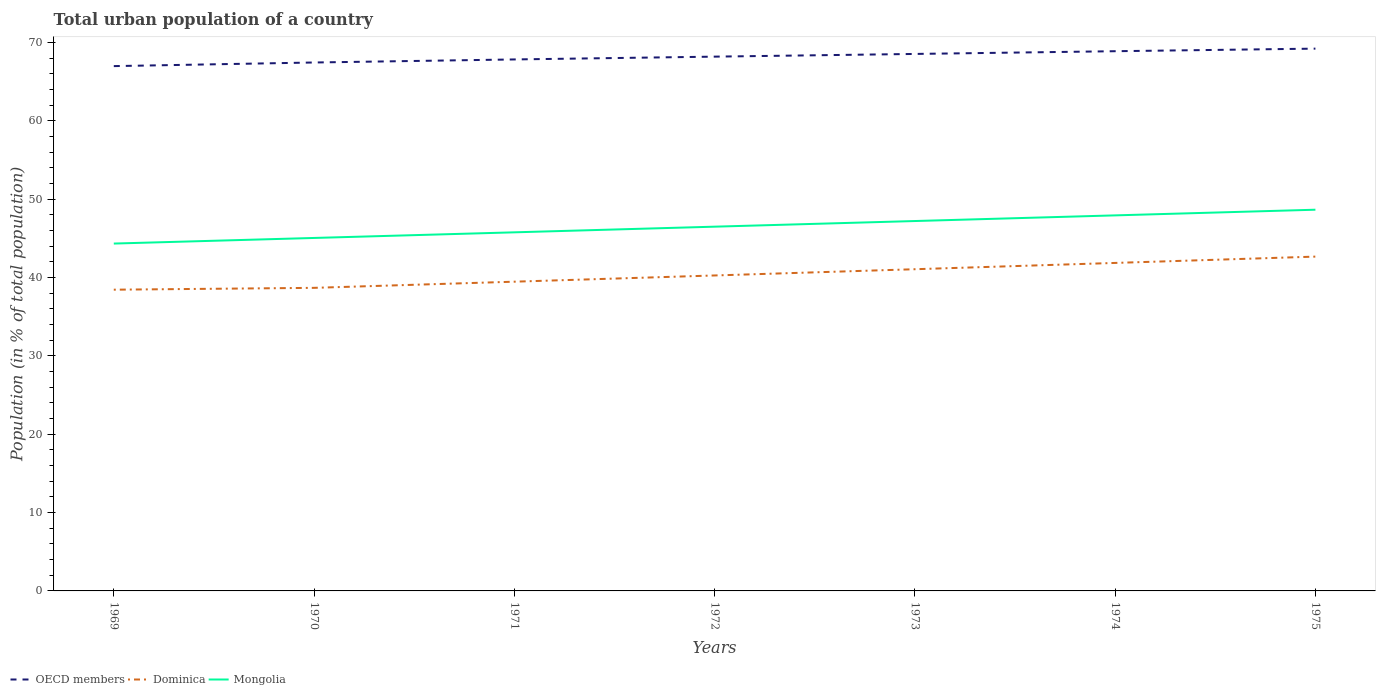How many different coloured lines are there?
Your response must be concise. 3. Is the number of lines equal to the number of legend labels?
Make the answer very short. Yes. Across all years, what is the maximum urban population in OECD members?
Your answer should be very brief. 66.98. In which year was the urban population in OECD members maximum?
Keep it short and to the point. 1969. What is the total urban population in Dominica in the graph?
Keep it short and to the point. -1.82. What is the difference between the highest and the second highest urban population in Dominica?
Your answer should be very brief. 4.22. What is the difference between the highest and the lowest urban population in Dominica?
Offer a terse response. 3. Is the urban population in Mongolia strictly greater than the urban population in OECD members over the years?
Offer a terse response. Yes. How many lines are there?
Provide a succinct answer. 3. Are the values on the major ticks of Y-axis written in scientific E-notation?
Your response must be concise. No. Does the graph contain grids?
Provide a short and direct response. No. Where does the legend appear in the graph?
Give a very brief answer. Bottom left. What is the title of the graph?
Make the answer very short. Total urban population of a country. What is the label or title of the X-axis?
Make the answer very short. Years. What is the label or title of the Y-axis?
Offer a very short reply. Population (in % of total population). What is the Population (in % of total population) of OECD members in 1969?
Provide a short and direct response. 66.98. What is the Population (in % of total population) in Dominica in 1969?
Your answer should be compact. 38.45. What is the Population (in % of total population) in Mongolia in 1969?
Your answer should be very brief. 44.34. What is the Population (in % of total population) of OECD members in 1970?
Your response must be concise. 67.45. What is the Population (in % of total population) in Dominica in 1970?
Offer a terse response. 38.68. What is the Population (in % of total population) in Mongolia in 1970?
Give a very brief answer. 45.05. What is the Population (in % of total population) in OECD members in 1971?
Offer a very short reply. 67.84. What is the Population (in % of total population) of Dominica in 1971?
Give a very brief answer. 39.47. What is the Population (in % of total population) in Mongolia in 1971?
Your response must be concise. 45.77. What is the Population (in % of total population) in OECD members in 1972?
Keep it short and to the point. 68.19. What is the Population (in % of total population) of Dominica in 1972?
Ensure brevity in your answer.  40.26. What is the Population (in % of total population) in Mongolia in 1972?
Keep it short and to the point. 46.49. What is the Population (in % of total population) in OECD members in 1973?
Keep it short and to the point. 68.54. What is the Population (in % of total population) in Dominica in 1973?
Offer a very short reply. 41.06. What is the Population (in % of total population) of Mongolia in 1973?
Your response must be concise. 47.21. What is the Population (in % of total population) of OECD members in 1974?
Provide a short and direct response. 68.89. What is the Population (in % of total population) of Dominica in 1974?
Your answer should be very brief. 41.86. What is the Population (in % of total population) of Mongolia in 1974?
Keep it short and to the point. 47.93. What is the Population (in % of total population) in OECD members in 1975?
Your answer should be compact. 69.22. What is the Population (in % of total population) of Dominica in 1975?
Give a very brief answer. 42.67. What is the Population (in % of total population) of Mongolia in 1975?
Provide a short and direct response. 48.66. Across all years, what is the maximum Population (in % of total population) of OECD members?
Give a very brief answer. 69.22. Across all years, what is the maximum Population (in % of total population) of Dominica?
Provide a short and direct response. 42.67. Across all years, what is the maximum Population (in % of total population) in Mongolia?
Offer a very short reply. 48.66. Across all years, what is the minimum Population (in % of total population) in OECD members?
Provide a short and direct response. 66.98. Across all years, what is the minimum Population (in % of total population) of Dominica?
Your answer should be compact. 38.45. Across all years, what is the minimum Population (in % of total population) of Mongolia?
Your answer should be very brief. 44.34. What is the total Population (in % of total population) in OECD members in the graph?
Give a very brief answer. 477.1. What is the total Population (in % of total population) of Dominica in the graph?
Ensure brevity in your answer.  282.46. What is the total Population (in % of total population) of Mongolia in the graph?
Your answer should be very brief. 325.45. What is the difference between the Population (in % of total population) in OECD members in 1969 and that in 1970?
Make the answer very short. -0.46. What is the difference between the Population (in % of total population) of Dominica in 1969 and that in 1970?
Give a very brief answer. -0.23. What is the difference between the Population (in % of total population) in Mongolia in 1969 and that in 1970?
Offer a very short reply. -0.72. What is the difference between the Population (in % of total population) in OECD members in 1969 and that in 1971?
Keep it short and to the point. -0.85. What is the difference between the Population (in % of total population) of Dominica in 1969 and that in 1971?
Give a very brief answer. -1.02. What is the difference between the Population (in % of total population) in Mongolia in 1969 and that in 1971?
Your answer should be very brief. -1.43. What is the difference between the Population (in % of total population) of OECD members in 1969 and that in 1972?
Your answer should be very brief. -1.21. What is the difference between the Population (in % of total population) of Dominica in 1969 and that in 1972?
Provide a succinct answer. -1.82. What is the difference between the Population (in % of total population) of Mongolia in 1969 and that in 1972?
Offer a very short reply. -2.15. What is the difference between the Population (in % of total population) of OECD members in 1969 and that in 1973?
Offer a very short reply. -1.55. What is the difference between the Population (in % of total population) of Dominica in 1969 and that in 1973?
Give a very brief answer. -2.61. What is the difference between the Population (in % of total population) of Mongolia in 1969 and that in 1973?
Offer a terse response. -2.88. What is the difference between the Population (in % of total population) of OECD members in 1969 and that in 1974?
Offer a very short reply. -1.9. What is the difference between the Population (in % of total population) in Dominica in 1969 and that in 1974?
Offer a terse response. -3.42. What is the difference between the Population (in % of total population) in Mongolia in 1969 and that in 1974?
Ensure brevity in your answer.  -3.6. What is the difference between the Population (in % of total population) in OECD members in 1969 and that in 1975?
Give a very brief answer. -2.23. What is the difference between the Population (in % of total population) of Dominica in 1969 and that in 1975?
Keep it short and to the point. -4.22. What is the difference between the Population (in % of total population) of Mongolia in 1969 and that in 1975?
Your answer should be compact. -4.32. What is the difference between the Population (in % of total population) in OECD members in 1970 and that in 1971?
Keep it short and to the point. -0.39. What is the difference between the Population (in % of total population) of Dominica in 1970 and that in 1971?
Offer a terse response. -0.79. What is the difference between the Population (in % of total population) in Mongolia in 1970 and that in 1971?
Provide a succinct answer. -0.72. What is the difference between the Population (in % of total population) of OECD members in 1970 and that in 1972?
Keep it short and to the point. -0.75. What is the difference between the Population (in % of total population) in Dominica in 1970 and that in 1972?
Your answer should be compact. -1.58. What is the difference between the Population (in % of total population) of Mongolia in 1970 and that in 1972?
Keep it short and to the point. -1.44. What is the difference between the Population (in % of total population) of OECD members in 1970 and that in 1973?
Offer a very short reply. -1.09. What is the difference between the Population (in % of total population) in Dominica in 1970 and that in 1973?
Offer a very short reply. -2.38. What is the difference between the Population (in % of total population) of Mongolia in 1970 and that in 1973?
Your response must be concise. -2.16. What is the difference between the Population (in % of total population) in OECD members in 1970 and that in 1974?
Offer a terse response. -1.44. What is the difference between the Population (in % of total population) in Dominica in 1970 and that in 1974?
Offer a terse response. -3.18. What is the difference between the Population (in % of total population) of Mongolia in 1970 and that in 1974?
Make the answer very short. -2.88. What is the difference between the Population (in % of total population) in OECD members in 1970 and that in 1975?
Ensure brevity in your answer.  -1.77. What is the difference between the Population (in % of total population) in Dominica in 1970 and that in 1975?
Your answer should be very brief. -3.99. What is the difference between the Population (in % of total population) in Mongolia in 1970 and that in 1975?
Your answer should be compact. -3.6. What is the difference between the Population (in % of total population) of OECD members in 1971 and that in 1972?
Offer a very short reply. -0.36. What is the difference between the Population (in % of total population) of Dominica in 1971 and that in 1972?
Offer a very short reply. -0.79. What is the difference between the Population (in % of total population) of Mongolia in 1971 and that in 1972?
Provide a short and direct response. -0.72. What is the difference between the Population (in % of total population) in OECD members in 1971 and that in 1973?
Give a very brief answer. -0.7. What is the difference between the Population (in % of total population) of Dominica in 1971 and that in 1973?
Provide a succinct answer. -1.59. What is the difference between the Population (in % of total population) in Mongolia in 1971 and that in 1973?
Your response must be concise. -1.44. What is the difference between the Population (in % of total population) of OECD members in 1971 and that in 1974?
Give a very brief answer. -1.05. What is the difference between the Population (in % of total population) in Dominica in 1971 and that in 1974?
Your answer should be very brief. -2.39. What is the difference between the Population (in % of total population) in Mongolia in 1971 and that in 1974?
Keep it short and to the point. -2.16. What is the difference between the Population (in % of total population) in OECD members in 1971 and that in 1975?
Your response must be concise. -1.38. What is the difference between the Population (in % of total population) of Dominica in 1971 and that in 1975?
Your answer should be compact. -3.2. What is the difference between the Population (in % of total population) in Mongolia in 1971 and that in 1975?
Ensure brevity in your answer.  -2.89. What is the difference between the Population (in % of total population) of OECD members in 1972 and that in 1973?
Offer a terse response. -0.34. What is the difference between the Population (in % of total population) of Dominica in 1972 and that in 1973?
Offer a very short reply. -0.8. What is the difference between the Population (in % of total population) of Mongolia in 1972 and that in 1973?
Offer a very short reply. -0.72. What is the difference between the Population (in % of total population) of OECD members in 1972 and that in 1974?
Provide a short and direct response. -0.69. What is the difference between the Population (in % of total population) in Mongolia in 1972 and that in 1974?
Ensure brevity in your answer.  -1.44. What is the difference between the Population (in % of total population) in OECD members in 1972 and that in 1975?
Your answer should be very brief. -1.02. What is the difference between the Population (in % of total population) in Dominica in 1972 and that in 1975?
Your response must be concise. -2.41. What is the difference between the Population (in % of total population) of Mongolia in 1972 and that in 1975?
Give a very brief answer. -2.17. What is the difference between the Population (in % of total population) of OECD members in 1973 and that in 1974?
Provide a short and direct response. -0.35. What is the difference between the Population (in % of total population) of Dominica in 1973 and that in 1974?
Your response must be concise. -0.8. What is the difference between the Population (in % of total population) of Mongolia in 1973 and that in 1974?
Keep it short and to the point. -0.72. What is the difference between the Population (in % of total population) of OECD members in 1973 and that in 1975?
Keep it short and to the point. -0.68. What is the difference between the Population (in % of total population) in Dominica in 1973 and that in 1975?
Offer a very short reply. -1.61. What is the difference between the Population (in % of total population) of Mongolia in 1973 and that in 1975?
Provide a succinct answer. -1.45. What is the difference between the Population (in % of total population) of OECD members in 1974 and that in 1975?
Your answer should be compact. -0.33. What is the difference between the Population (in % of total population) of Dominica in 1974 and that in 1975?
Provide a short and direct response. -0.81. What is the difference between the Population (in % of total population) in Mongolia in 1974 and that in 1975?
Provide a short and direct response. -0.72. What is the difference between the Population (in % of total population) of OECD members in 1969 and the Population (in % of total population) of Dominica in 1970?
Keep it short and to the point. 28.3. What is the difference between the Population (in % of total population) in OECD members in 1969 and the Population (in % of total population) in Mongolia in 1970?
Your answer should be very brief. 21.93. What is the difference between the Population (in % of total population) of Dominica in 1969 and the Population (in % of total population) of Mongolia in 1970?
Keep it short and to the point. -6.6. What is the difference between the Population (in % of total population) of OECD members in 1969 and the Population (in % of total population) of Dominica in 1971?
Ensure brevity in your answer.  27.51. What is the difference between the Population (in % of total population) of OECD members in 1969 and the Population (in % of total population) of Mongolia in 1971?
Your answer should be compact. 21.21. What is the difference between the Population (in % of total population) of Dominica in 1969 and the Population (in % of total population) of Mongolia in 1971?
Provide a succinct answer. -7.32. What is the difference between the Population (in % of total population) of OECD members in 1969 and the Population (in % of total population) of Dominica in 1972?
Provide a succinct answer. 26.72. What is the difference between the Population (in % of total population) in OECD members in 1969 and the Population (in % of total population) in Mongolia in 1972?
Give a very brief answer. 20.49. What is the difference between the Population (in % of total population) in Dominica in 1969 and the Population (in % of total population) in Mongolia in 1972?
Provide a succinct answer. -8.04. What is the difference between the Population (in % of total population) of OECD members in 1969 and the Population (in % of total population) of Dominica in 1973?
Offer a terse response. 25.92. What is the difference between the Population (in % of total population) in OECD members in 1969 and the Population (in % of total population) in Mongolia in 1973?
Give a very brief answer. 19.77. What is the difference between the Population (in % of total population) in Dominica in 1969 and the Population (in % of total population) in Mongolia in 1973?
Your answer should be compact. -8.76. What is the difference between the Population (in % of total population) of OECD members in 1969 and the Population (in % of total population) of Dominica in 1974?
Keep it short and to the point. 25.12. What is the difference between the Population (in % of total population) of OECD members in 1969 and the Population (in % of total population) of Mongolia in 1974?
Offer a very short reply. 19.05. What is the difference between the Population (in % of total population) in Dominica in 1969 and the Population (in % of total population) in Mongolia in 1974?
Give a very brief answer. -9.48. What is the difference between the Population (in % of total population) of OECD members in 1969 and the Population (in % of total population) of Dominica in 1975?
Keep it short and to the point. 24.31. What is the difference between the Population (in % of total population) in OECD members in 1969 and the Population (in % of total population) in Mongolia in 1975?
Your response must be concise. 18.33. What is the difference between the Population (in % of total population) in Dominica in 1969 and the Population (in % of total population) in Mongolia in 1975?
Provide a succinct answer. -10.21. What is the difference between the Population (in % of total population) in OECD members in 1970 and the Population (in % of total population) in Dominica in 1971?
Offer a terse response. 27.98. What is the difference between the Population (in % of total population) of OECD members in 1970 and the Population (in % of total population) of Mongolia in 1971?
Your response must be concise. 21.68. What is the difference between the Population (in % of total population) of Dominica in 1970 and the Population (in % of total population) of Mongolia in 1971?
Provide a short and direct response. -7.09. What is the difference between the Population (in % of total population) in OECD members in 1970 and the Population (in % of total population) in Dominica in 1972?
Your response must be concise. 27.18. What is the difference between the Population (in % of total population) in OECD members in 1970 and the Population (in % of total population) in Mongolia in 1972?
Offer a very short reply. 20.95. What is the difference between the Population (in % of total population) of Dominica in 1970 and the Population (in % of total population) of Mongolia in 1972?
Your answer should be compact. -7.81. What is the difference between the Population (in % of total population) in OECD members in 1970 and the Population (in % of total population) in Dominica in 1973?
Give a very brief answer. 26.38. What is the difference between the Population (in % of total population) of OECD members in 1970 and the Population (in % of total population) of Mongolia in 1973?
Provide a short and direct response. 20.23. What is the difference between the Population (in % of total population) in Dominica in 1970 and the Population (in % of total population) in Mongolia in 1973?
Provide a succinct answer. -8.53. What is the difference between the Population (in % of total population) in OECD members in 1970 and the Population (in % of total population) in Dominica in 1974?
Provide a short and direct response. 25.58. What is the difference between the Population (in % of total population) of OECD members in 1970 and the Population (in % of total population) of Mongolia in 1974?
Provide a short and direct response. 19.51. What is the difference between the Population (in % of total population) in Dominica in 1970 and the Population (in % of total population) in Mongolia in 1974?
Keep it short and to the point. -9.25. What is the difference between the Population (in % of total population) of OECD members in 1970 and the Population (in % of total population) of Dominica in 1975?
Ensure brevity in your answer.  24.77. What is the difference between the Population (in % of total population) of OECD members in 1970 and the Population (in % of total population) of Mongolia in 1975?
Make the answer very short. 18.79. What is the difference between the Population (in % of total population) of Dominica in 1970 and the Population (in % of total population) of Mongolia in 1975?
Make the answer very short. -9.97. What is the difference between the Population (in % of total population) in OECD members in 1971 and the Population (in % of total population) in Dominica in 1972?
Ensure brevity in your answer.  27.57. What is the difference between the Population (in % of total population) of OECD members in 1971 and the Population (in % of total population) of Mongolia in 1972?
Offer a very short reply. 21.34. What is the difference between the Population (in % of total population) of Dominica in 1971 and the Population (in % of total population) of Mongolia in 1972?
Provide a short and direct response. -7.02. What is the difference between the Population (in % of total population) in OECD members in 1971 and the Population (in % of total population) in Dominica in 1973?
Offer a terse response. 26.77. What is the difference between the Population (in % of total population) in OECD members in 1971 and the Population (in % of total population) in Mongolia in 1973?
Your answer should be compact. 20.62. What is the difference between the Population (in % of total population) of Dominica in 1971 and the Population (in % of total population) of Mongolia in 1973?
Your answer should be very brief. -7.74. What is the difference between the Population (in % of total population) in OECD members in 1971 and the Population (in % of total population) in Dominica in 1974?
Offer a terse response. 25.97. What is the difference between the Population (in % of total population) in OECD members in 1971 and the Population (in % of total population) in Mongolia in 1974?
Keep it short and to the point. 19.9. What is the difference between the Population (in % of total population) of Dominica in 1971 and the Population (in % of total population) of Mongolia in 1974?
Provide a succinct answer. -8.46. What is the difference between the Population (in % of total population) of OECD members in 1971 and the Population (in % of total population) of Dominica in 1975?
Provide a short and direct response. 25.16. What is the difference between the Population (in % of total population) of OECD members in 1971 and the Population (in % of total population) of Mongolia in 1975?
Provide a succinct answer. 19.18. What is the difference between the Population (in % of total population) of Dominica in 1971 and the Population (in % of total population) of Mongolia in 1975?
Provide a short and direct response. -9.19. What is the difference between the Population (in % of total population) of OECD members in 1972 and the Population (in % of total population) of Dominica in 1973?
Your answer should be compact. 27.13. What is the difference between the Population (in % of total population) in OECD members in 1972 and the Population (in % of total population) in Mongolia in 1973?
Make the answer very short. 20.98. What is the difference between the Population (in % of total population) in Dominica in 1972 and the Population (in % of total population) in Mongolia in 1973?
Your answer should be very brief. -6.95. What is the difference between the Population (in % of total population) of OECD members in 1972 and the Population (in % of total population) of Dominica in 1974?
Your answer should be compact. 26.33. What is the difference between the Population (in % of total population) of OECD members in 1972 and the Population (in % of total population) of Mongolia in 1974?
Keep it short and to the point. 20.26. What is the difference between the Population (in % of total population) of Dominica in 1972 and the Population (in % of total population) of Mongolia in 1974?
Offer a very short reply. -7.67. What is the difference between the Population (in % of total population) in OECD members in 1972 and the Population (in % of total population) in Dominica in 1975?
Your response must be concise. 25.52. What is the difference between the Population (in % of total population) in OECD members in 1972 and the Population (in % of total population) in Mongolia in 1975?
Offer a very short reply. 19.54. What is the difference between the Population (in % of total population) of Dominica in 1972 and the Population (in % of total population) of Mongolia in 1975?
Ensure brevity in your answer.  -8.39. What is the difference between the Population (in % of total population) in OECD members in 1973 and the Population (in % of total population) in Dominica in 1974?
Give a very brief answer. 26.67. What is the difference between the Population (in % of total population) of OECD members in 1973 and the Population (in % of total population) of Mongolia in 1974?
Give a very brief answer. 20.6. What is the difference between the Population (in % of total population) of Dominica in 1973 and the Population (in % of total population) of Mongolia in 1974?
Keep it short and to the point. -6.87. What is the difference between the Population (in % of total population) in OECD members in 1973 and the Population (in % of total population) in Dominica in 1975?
Make the answer very short. 25.87. What is the difference between the Population (in % of total population) of OECD members in 1973 and the Population (in % of total population) of Mongolia in 1975?
Your answer should be compact. 19.88. What is the difference between the Population (in % of total population) of Dominica in 1973 and the Population (in % of total population) of Mongolia in 1975?
Ensure brevity in your answer.  -7.59. What is the difference between the Population (in % of total population) in OECD members in 1974 and the Population (in % of total population) in Dominica in 1975?
Your answer should be compact. 26.22. What is the difference between the Population (in % of total population) of OECD members in 1974 and the Population (in % of total population) of Mongolia in 1975?
Your answer should be very brief. 20.23. What is the difference between the Population (in % of total population) of Dominica in 1974 and the Population (in % of total population) of Mongolia in 1975?
Give a very brief answer. -6.79. What is the average Population (in % of total population) of OECD members per year?
Your answer should be compact. 68.16. What is the average Population (in % of total population) in Dominica per year?
Your answer should be very brief. 40.35. What is the average Population (in % of total population) of Mongolia per year?
Your response must be concise. 46.49. In the year 1969, what is the difference between the Population (in % of total population) in OECD members and Population (in % of total population) in Dominica?
Make the answer very short. 28.54. In the year 1969, what is the difference between the Population (in % of total population) in OECD members and Population (in % of total population) in Mongolia?
Give a very brief answer. 22.65. In the year 1969, what is the difference between the Population (in % of total population) of Dominica and Population (in % of total population) of Mongolia?
Provide a short and direct response. -5.89. In the year 1970, what is the difference between the Population (in % of total population) in OECD members and Population (in % of total population) in Dominica?
Offer a very short reply. 28.76. In the year 1970, what is the difference between the Population (in % of total population) in OECD members and Population (in % of total population) in Mongolia?
Offer a terse response. 22.39. In the year 1970, what is the difference between the Population (in % of total population) of Dominica and Population (in % of total population) of Mongolia?
Give a very brief answer. -6.37. In the year 1971, what is the difference between the Population (in % of total population) of OECD members and Population (in % of total population) of Dominica?
Give a very brief answer. 28.37. In the year 1971, what is the difference between the Population (in % of total population) of OECD members and Population (in % of total population) of Mongolia?
Provide a succinct answer. 22.07. In the year 1972, what is the difference between the Population (in % of total population) of OECD members and Population (in % of total population) of Dominica?
Offer a terse response. 27.93. In the year 1972, what is the difference between the Population (in % of total population) in OECD members and Population (in % of total population) in Mongolia?
Provide a succinct answer. 21.7. In the year 1972, what is the difference between the Population (in % of total population) in Dominica and Population (in % of total population) in Mongolia?
Your answer should be compact. -6.23. In the year 1973, what is the difference between the Population (in % of total population) of OECD members and Population (in % of total population) of Dominica?
Your answer should be very brief. 27.48. In the year 1973, what is the difference between the Population (in % of total population) of OECD members and Population (in % of total population) of Mongolia?
Your answer should be very brief. 21.33. In the year 1973, what is the difference between the Population (in % of total population) in Dominica and Population (in % of total population) in Mongolia?
Provide a succinct answer. -6.15. In the year 1974, what is the difference between the Population (in % of total population) of OECD members and Population (in % of total population) of Dominica?
Offer a very short reply. 27.02. In the year 1974, what is the difference between the Population (in % of total population) of OECD members and Population (in % of total population) of Mongolia?
Ensure brevity in your answer.  20.95. In the year 1974, what is the difference between the Population (in % of total population) in Dominica and Population (in % of total population) in Mongolia?
Offer a terse response. -6.07. In the year 1975, what is the difference between the Population (in % of total population) in OECD members and Population (in % of total population) in Dominica?
Your answer should be very brief. 26.54. In the year 1975, what is the difference between the Population (in % of total population) in OECD members and Population (in % of total population) in Mongolia?
Provide a succinct answer. 20.56. In the year 1975, what is the difference between the Population (in % of total population) of Dominica and Population (in % of total population) of Mongolia?
Offer a terse response. -5.99. What is the ratio of the Population (in % of total population) in OECD members in 1969 to that in 1970?
Give a very brief answer. 0.99. What is the ratio of the Population (in % of total population) of Mongolia in 1969 to that in 1970?
Ensure brevity in your answer.  0.98. What is the ratio of the Population (in % of total population) in OECD members in 1969 to that in 1971?
Your answer should be compact. 0.99. What is the ratio of the Population (in % of total population) in Dominica in 1969 to that in 1971?
Your answer should be very brief. 0.97. What is the ratio of the Population (in % of total population) of Mongolia in 1969 to that in 1971?
Your answer should be very brief. 0.97. What is the ratio of the Population (in % of total population) in OECD members in 1969 to that in 1972?
Offer a terse response. 0.98. What is the ratio of the Population (in % of total population) in Dominica in 1969 to that in 1972?
Give a very brief answer. 0.95. What is the ratio of the Population (in % of total population) in Mongolia in 1969 to that in 1972?
Provide a succinct answer. 0.95. What is the ratio of the Population (in % of total population) of OECD members in 1969 to that in 1973?
Ensure brevity in your answer.  0.98. What is the ratio of the Population (in % of total population) in Dominica in 1969 to that in 1973?
Ensure brevity in your answer.  0.94. What is the ratio of the Population (in % of total population) of Mongolia in 1969 to that in 1973?
Keep it short and to the point. 0.94. What is the ratio of the Population (in % of total population) of OECD members in 1969 to that in 1974?
Your answer should be compact. 0.97. What is the ratio of the Population (in % of total population) of Dominica in 1969 to that in 1974?
Ensure brevity in your answer.  0.92. What is the ratio of the Population (in % of total population) in Mongolia in 1969 to that in 1974?
Offer a terse response. 0.93. What is the ratio of the Population (in % of total population) in OECD members in 1969 to that in 1975?
Your answer should be very brief. 0.97. What is the ratio of the Population (in % of total population) in Dominica in 1969 to that in 1975?
Keep it short and to the point. 0.9. What is the ratio of the Population (in % of total population) of Mongolia in 1969 to that in 1975?
Your answer should be very brief. 0.91. What is the ratio of the Population (in % of total population) of OECD members in 1970 to that in 1971?
Make the answer very short. 0.99. What is the ratio of the Population (in % of total population) of Dominica in 1970 to that in 1971?
Your answer should be compact. 0.98. What is the ratio of the Population (in % of total population) in Mongolia in 1970 to that in 1971?
Make the answer very short. 0.98. What is the ratio of the Population (in % of total population) of OECD members in 1970 to that in 1972?
Offer a very short reply. 0.99. What is the ratio of the Population (in % of total population) in Dominica in 1970 to that in 1972?
Provide a short and direct response. 0.96. What is the ratio of the Population (in % of total population) in Mongolia in 1970 to that in 1972?
Provide a short and direct response. 0.97. What is the ratio of the Population (in % of total population) in OECD members in 1970 to that in 1973?
Your answer should be compact. 0.98. What is the ratio of the Population (in % of total population) in Dominica in 1970 to that in 1973?
Give a very brief answer. 0.94. What is the ratio of the Population (in % of total population) in Mongolia in 1970 to that in 1973?
Your answer should be very brief. 0.95. What is the ratio of the Population (in % of total population) in OECD members in 1970 to that in 1974?
Provide a succinct answer. 0.98. What is the ratio of the Population (in % of total population) of Dominica in 1970 to that in 1974?
Give a very brief answer. 0.92. What is the ratio of the Population (in % of total population) of Mongolia in 1970 to that in 1974?
Provide a short and direct response. 0.94. What is the ratio of the Population (in % of total population) of OECD members in 1970 to that in 1975?
Provide a short and direct response. 0.97. What is the ratio of the Population (in % of total population) of Dominica in 1970 to that in 1975?
Your answer should be compact. 0.91. What is the ratio of the Population (in % of total population) of Mongolia in 1970 to that in 1975?
Offer a very short reply. 0.93. What is the ratio of the Population (in % of total population) of Dominica in 1971 to that in 1972?
Provide a succinct answer. 0.98. What is the ratio of the Population (in % of total population) of Mongolia in 1971 to that in 1972?
Provide a short and direct response. 0.98. What is the ratio of the Population (in % of total population) of OECD members in 1971 to that in 1973?
Keep it short and to the point. 0.99. What is the ratio of the Population (in % of total population) of Dominica in 1971 to that in 1973?
Provide a succinct answer. 0.96. What is the ratio of the Population (in % of total population) in Mongolia in 1971 to that in 1973?
Ensure brevity in your answer.  0.97. What is the ratio of the Population (in % of total population) in OECD members in 1971 to that in 1974?
Provide a succinct answer. 0.98. What is the ratio of the Population (in % of total population) in Dominica in 1971 to that in 1974?
Your response must be concise. 0.94. What is the ratio of the Population (in % of total population) in Mongolia in 1971 to that in 1974?
Give a very brief answer. 0.95. What is the ratio of the Population (in % of total population) of OECD members in 1971 to that in 1975?
Ensure brevity in your answer.  0.98. What is the ratio of the Population (in % of total population) of Dominica in 1971 to that in 1975?
Provide a succinct answer. 0.93. What is the ratio of the Population (in % of total population) in Mongolia in 1971 to that in 1975?
Provide a short and direct response. 0.94. What is the ratio of the Population (in % of total population) in Dominica in 1972 to that in 1973?
Your response must be concise. 0.98. What is the ratio of the Population (in % of total population) in Mongolia in 1972 to that in 1973?
Make the answer very short. 0.98. What is the ratio of the Population (in % of total population) in Dominica in 1972 to that in 1974?
Offer a terse response. 0.96. What is the ratio of the Population (in % of total population) in Mongolia in 1972 to that in 1974?
Keep it short and to the point. 0.97. What is the ratio of the Population (in % of total population) in OECD members in 1972 to that in 1975?
Keep it short and to the point. 0.99. What is the ratio of the Population (in % of total population) of Dominica in 1972 to that in 1975?
Keep it short and to the point. 0.94. What is the ratio of the Population (in % of total population) of Mongolia in 1972 to that in 1975?
Keep it short and to the point. 0.96. What is the ratio of the Population (in % of total population) of OECD members in 1973 to that in 1974?
Your answer should be very brief. 0.99. What is the ratio of the Population (in % of total population) in Dominica in 1973 to that in 1974?
Offer a terse response. 0.98. What is the ratio of the Population (in % of total population) in Mongolia in 1973 to that in 1974?
Keep it short and to the point. 0.98. What is the ratio of the Population (in % of total population) in OECD members in 1973 to that in 1975?
Give a very brief answer. 0.99. What is the ratio of the Population (in % of total population) of Dominica in 1973 to that in 1975?
Offer a very short reply. 0.96. What is the ratio of the Population (in % of total population) in Mongolia in 1973 to that in 1975?
Make the answer very short. 0.97. What is the ratio of the Population (in % of total population) of Dominica in 1974 to that in 1975?
Provide a succinct answer. 0.98. What is the ratio of the Population (in % of total population) of Mongolia in 1974 to that in 1975?
Provide a succinct answer. 0.99. What is the difference between the highest and the second highest Population (in % of total population) in OECD members?
Keep it short and to the point. 0.33. What is the difference between the highest and the second highest Population (in % of total population) in Dominica?
Offer a terse response. 0.81. What is the difference between the highest and the second highest Population (in % of total population) of Mongolia?
Give a very brief answer. 0.72. What is the difference between the highest and the lowest Population (in % of total population) of OECD members?
Make the answer very short. 2.23. What is the difference between the highest and the lowest Population (in % of total population) in Dominica?
Your answer should be compact. 4.22. What is the difference between the highest and the lowest Population (in % of total population) of Mongolia?
Give a very brief answer. 4.32. 